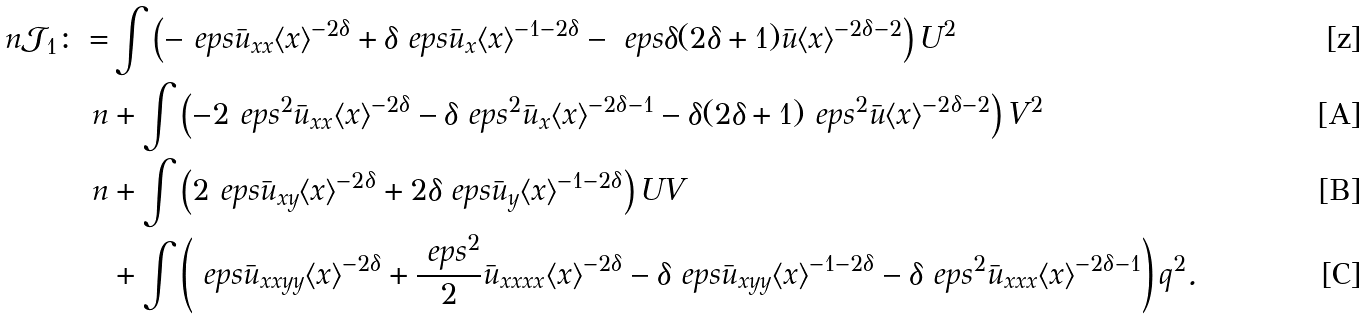<formula> <loc_0><loc_0><loc_500><loc_500>\ n \mathcal { J } _ { 1 } \colon = & \int \left ( - \ e p s \bar { u } _ { x x } \langle x \rangle ^ { - 2 \delta } + \delta \ e p s \bar { u } _ { x } \langle x \rangle ^ { - 1 - 2 \delta } - \ e p s \delta ( 2 \delta + 1 ) \bar { u } \langle x \rangle ^ { - 2 \delta - 2 } \right ) U ^ { 2 } \\ \ n & + \int \left ( - 2 \ e p s ^ { 2 } \bar { u } _ { x x } \langle x \rangle ^ { - 2 \delta } - \delta \ e p s ^ { 2 } \bar { u } _ { x } \langle x \rangle ^ { - 2 \delta - 1 } - \delta ( 2 \delta + 1 ) \ e p s ^ { 2 } \bar { u } \langle x \rangle ^ { - 2 \delta - 2 } \right ) V ^ { 2 } \\ \ n & + \int \left ( 2 \ e p s \bar { u } _ { x y } \langle x \rangle ^ { - 2 \delta } + 2 \delta \ e p s \bar { u } _ { y } \langle x \rangle ^ { - 1 - 2 \delta } \right ) U V \\ & + \int \left ( \ e p s \bar { u } _ { x x y y } \langle x \rangle ^ { - 2 \delta } + \frac { \ e p s ^ { 2 } } { 2 } \bar { u } _ { x x x x } \langle x \rangle ^ { - 2 \delta } - \delta \ e p s \bar { u } _ { x y y } \langle x \rangle ^ { - 1 - 2 \delta } - \delta \ e p s ^ { 2 } \bar { u } _ { x x x } \langle x \rangle ^ { - 2 \delta - 1 } \right ) q ^ { 2 } .</formula> 